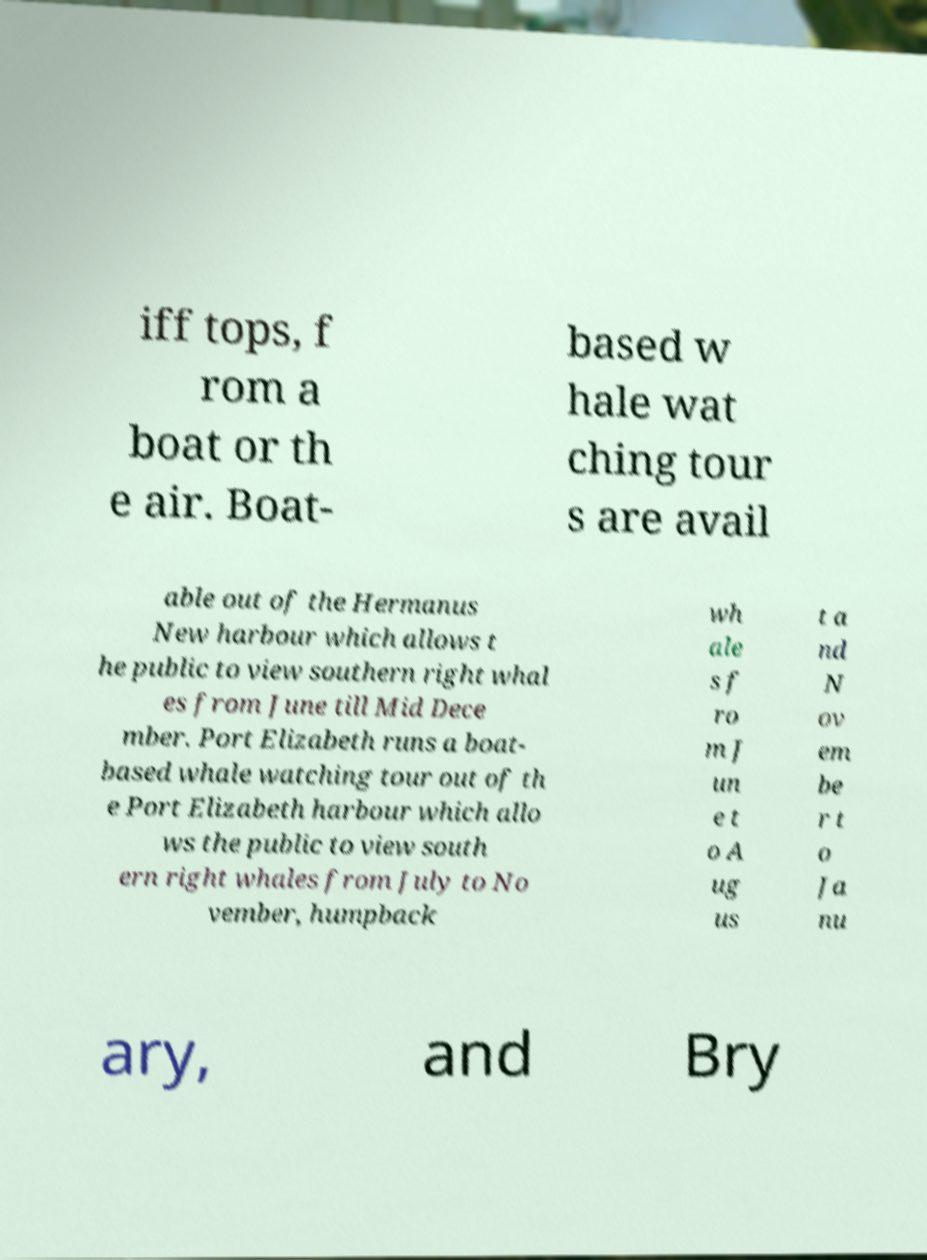I need the written content from this picture converted into text. Can you do that? iff tops, f rom a boat or th e air. Boat- based w hale wat ching tour s are avail able out of the Hermanus New harbour which allows t he public to view southern right whal es from June till Mid Dece mber. Port Elizabeth runs a boat- based whale watching tour out of th e Port Elizabeth harbour which allo ws the public to view south ern right whales from July to No vember, humpback wh ale s f ro m J un e t o A ug us t a nd N ov em be r t o Ja nu ary, and Bry 